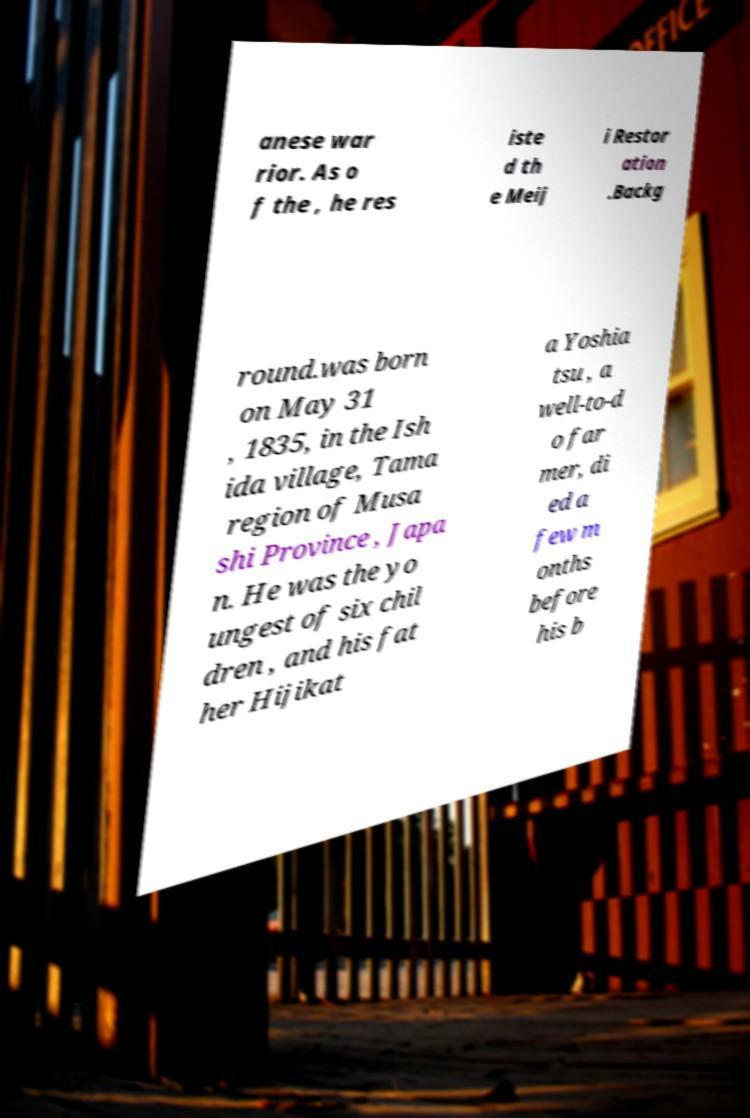What messages or text are displayed in this image? I need them in a readable, typed format. anese war rior. As o f the , he res iste d th e Meij i Restor ation .Backg round.was born on May 31 , 1835, in the Ish ida village, Tama region of Musa shi Province , Japa n. He was the yo ungest of six chil dren , and his fat her Hijikat a Yoshia tsu , a well-to-d o far mer, di ed a few m onths before his b 